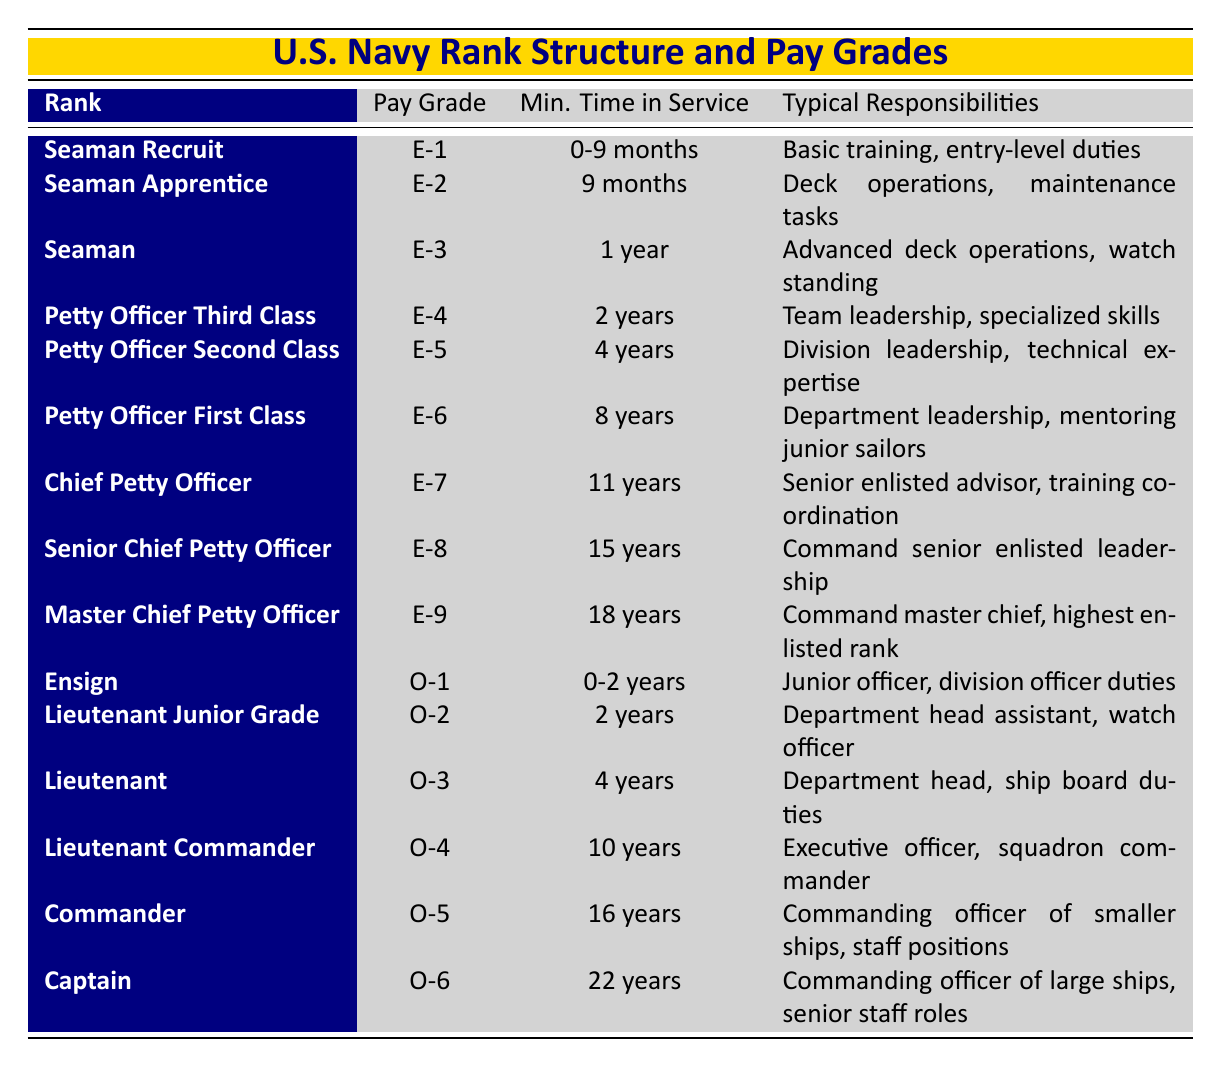What is the highest enlisted rank in the Navy? The highest enlisted rank listed in the table is "Master Chief Petty Officer," which corresponds to the pay grade of "E-9."
Answer: Master Chief Petty Officer How many years of service does a Chief Petty Officer require at minimum? To achieve the rank of Chief Petty Officer, a minimum of 11 years of service is required as indicated in the table.
Answer: 11 years Which officer rank comes after Lieutenant Junior Grade? The officer rank that comes after Lieutenant Junior Grade (O-2) is "Lieutenant" (O-3), as seen in the table.
Answer: Lieutenant Are there more enlisted ranks than officer ranks in the Navy? Yes, there are 9 enlisted ranks and 6 officer ranks listed in the table, confirming that there are more enlisted ranks than officer ranks.
Answer: Yes What is the typical responsibility of a Petty Officer First Class? According to the table, the typical responsibility of a Petty Officer First Class includes department leadership and mentoring junior sailors.
Answer: Department leadership, mentoring junior sailors What is the average minimum time in service required for the enlisted ranks listed? The minimum time in service for enlisted ranks is 0-9 months, 9 months, 1 year, 2 years, 4 years, 8 years, 11 years, 15 years, and 18 years. To find the average, add these values (first convert into months: 0, 9, 12, 24, 48, 96, 132, 180, and 216). The total is 717 months, with 9 ranks, so the average is 717/9 = 79.67 months or approximately 6.64 years.
Answer: Approximately 6.64 years Which rank requires the most years of service before promotion? The rank that requires the most years of service before promotion is "Captain," which requires a minimum of 22 years of service, as indicated in the table.
Answer: Captain What are the typical responsibilities of the rank with the pay grade E-5? The typical responsibilities for a rank with pay grade E-5, which is Petty Officer Second Class, include division leadership and technical expertise according to the information in the table.
Answer: Division leadership, technical expertise How many years prior to becoming a Commander does one need to serve at a minimum? A minimum of 16 years of service is required prior to becoming a Commander, as shown in the table.
Answer: 16 years 